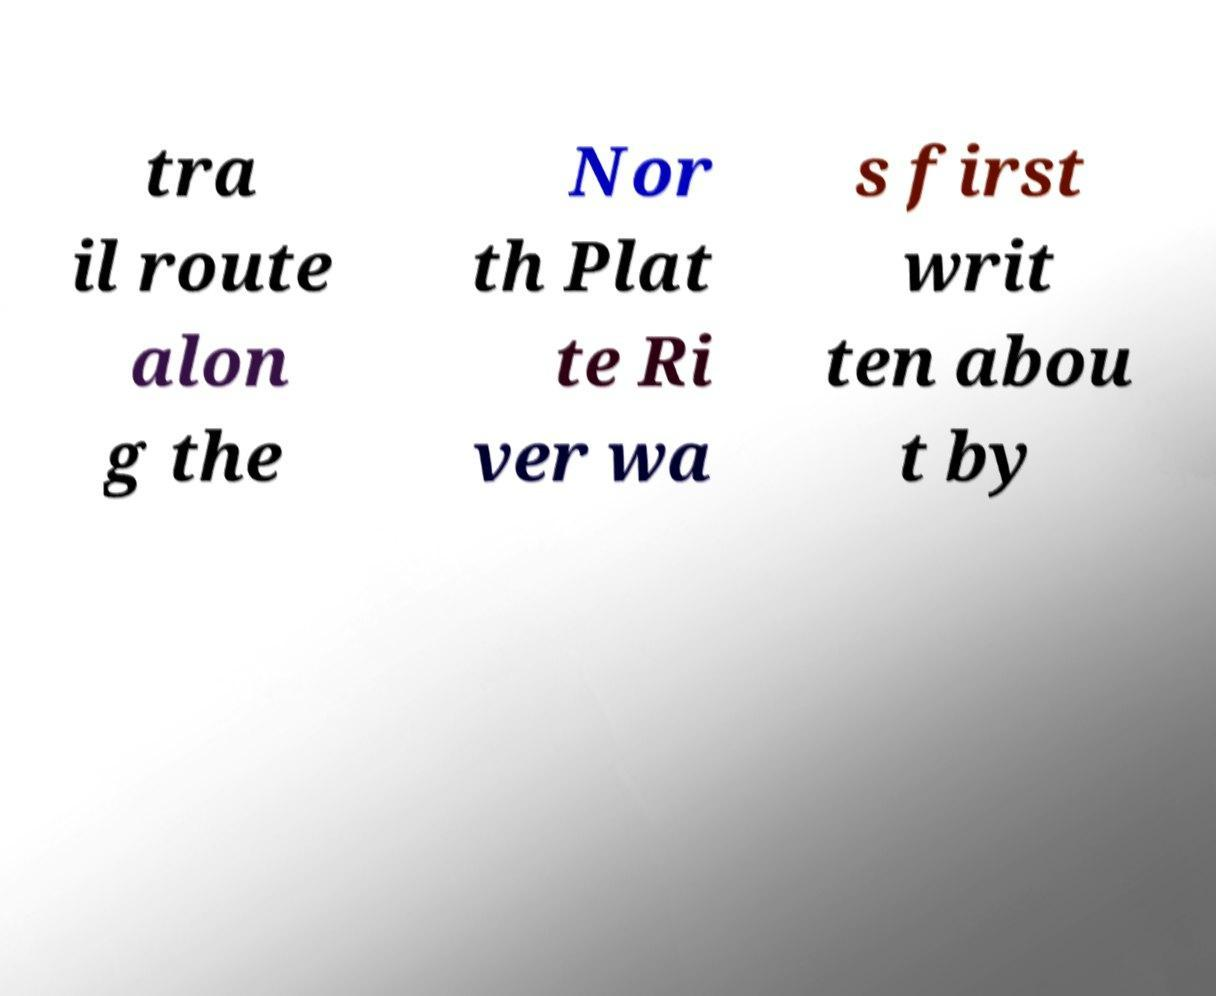Please identify and transcribe the text found in this image. tra il route alon g the Nor th Plat te Ri ver wa s first writ ten abou t by 